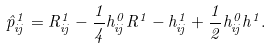Convert formula to latex. <formula><loc_0><loc_0><loc_500><loc_500>\hat { p } ^ { 1 } _ { i j } = R ^ { 1 } _ { i j } - \frac { 1 } { 4 } h ^ { 0 } _ { i j } R ^ { 1 } - h ^ { 1 } _ { i j } + \frac { 1 } { 2 } h ^ { 0 } _ { i j } h ^ { 1 } .</formula> 